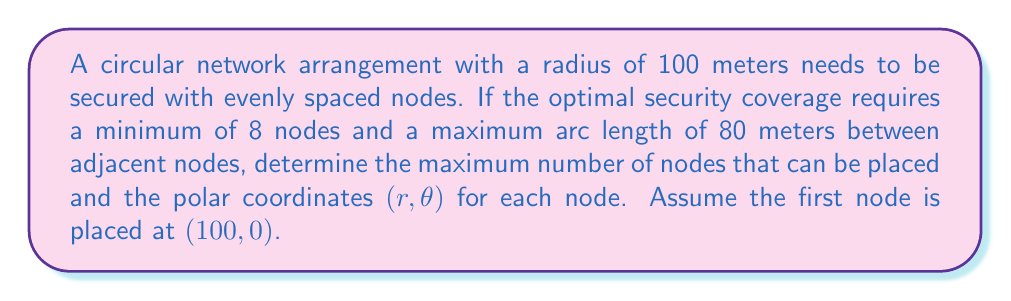Give your solution to this math problem. To solve this problem, we'll follow these steps:

1) First, let's calculate the maximum angle between adjacent nodes that satisfies the 80-meter arc length requirement:

   Arc length = $r\theta$, where $r$ is the radius and $\theta$ is in radians
   $80 = 100\theta$
   $\theta = \frac{80}{100} = 0.8$ radians

2) Now, let's convert this to degrees:
   $0.8 \text{ radians} \times \frac{180°}{\pi} \approx 45.84°$

3) To find the maximum number of nodes, we divide the full circle (360°) by this angle:
   $\frac{360°}{45.84°} \approx 7.85$

4) Since we need a whole number of nodes and it must be at least 8, we round down to 8 nodes.

5) With 8 nodes, the actual angle between adjacent nodes will be:
   $\frac{360°}{8} = 45°$ or $\frac{\pi}{4}$ radians

6) Now we can determine the polar coordinates for each node:
   - Node 1: $(100, 0)$ (given)
   - Node 2: $(100, \frac{\pi}{4})$
   - Node 3: $(100, \frac{\pi}{2})$
   - Node 4: $(100, \frac{3\pi}{4})$
   - Node 5: $(100, \pi)$
   - Node 6: $(100, \frac{5\pi}{4})$
   - Node 7: $(100, \frac{3\pi}{2})$
   - Node 8: $(100, \frac{7\pi}{4})$

This arrangement ensures that the nodes are evenly spaced and the arc length between adjacent nodes is less than 80 meters, satisfying the security requirements.
Answer: Maximum number of nodes: 8

Polar coordinates $(r,\theta)$ for each node:
$$(100,0), (100,\frac{\pi}{4}), (100,\frac{\pi}{2}), (100,\frac{3\pi}{4}), (100,\pi), (100,\frac{5\pi}{4}), (100,\frac{3\pi}{2}), (100,\frac{7\pi}{4})$$ 